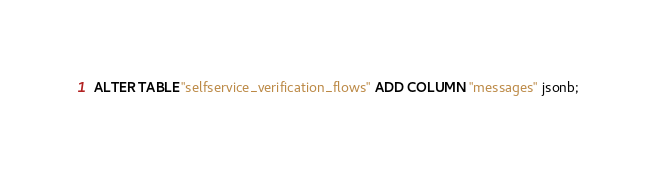Convert code to text. <code><loc_0><loc_0><loc_500><loc_500><_SQL_>ALTER TABLE "selfservice_verification_flows" ADD COLUMN "messages" jsonb;</code> 